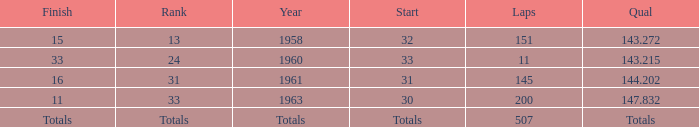What year did the finish of 15 happen in? 1958.0. 